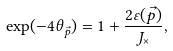<formula> <loc_0><loc_0><loc_500><loc_500>\exp ( - 4 \theta _ { \vec { p } } ) = 1 + \frac { 2 \varepsilon ( \vec { p } ) } { J _ { \times } } ,</formula> 